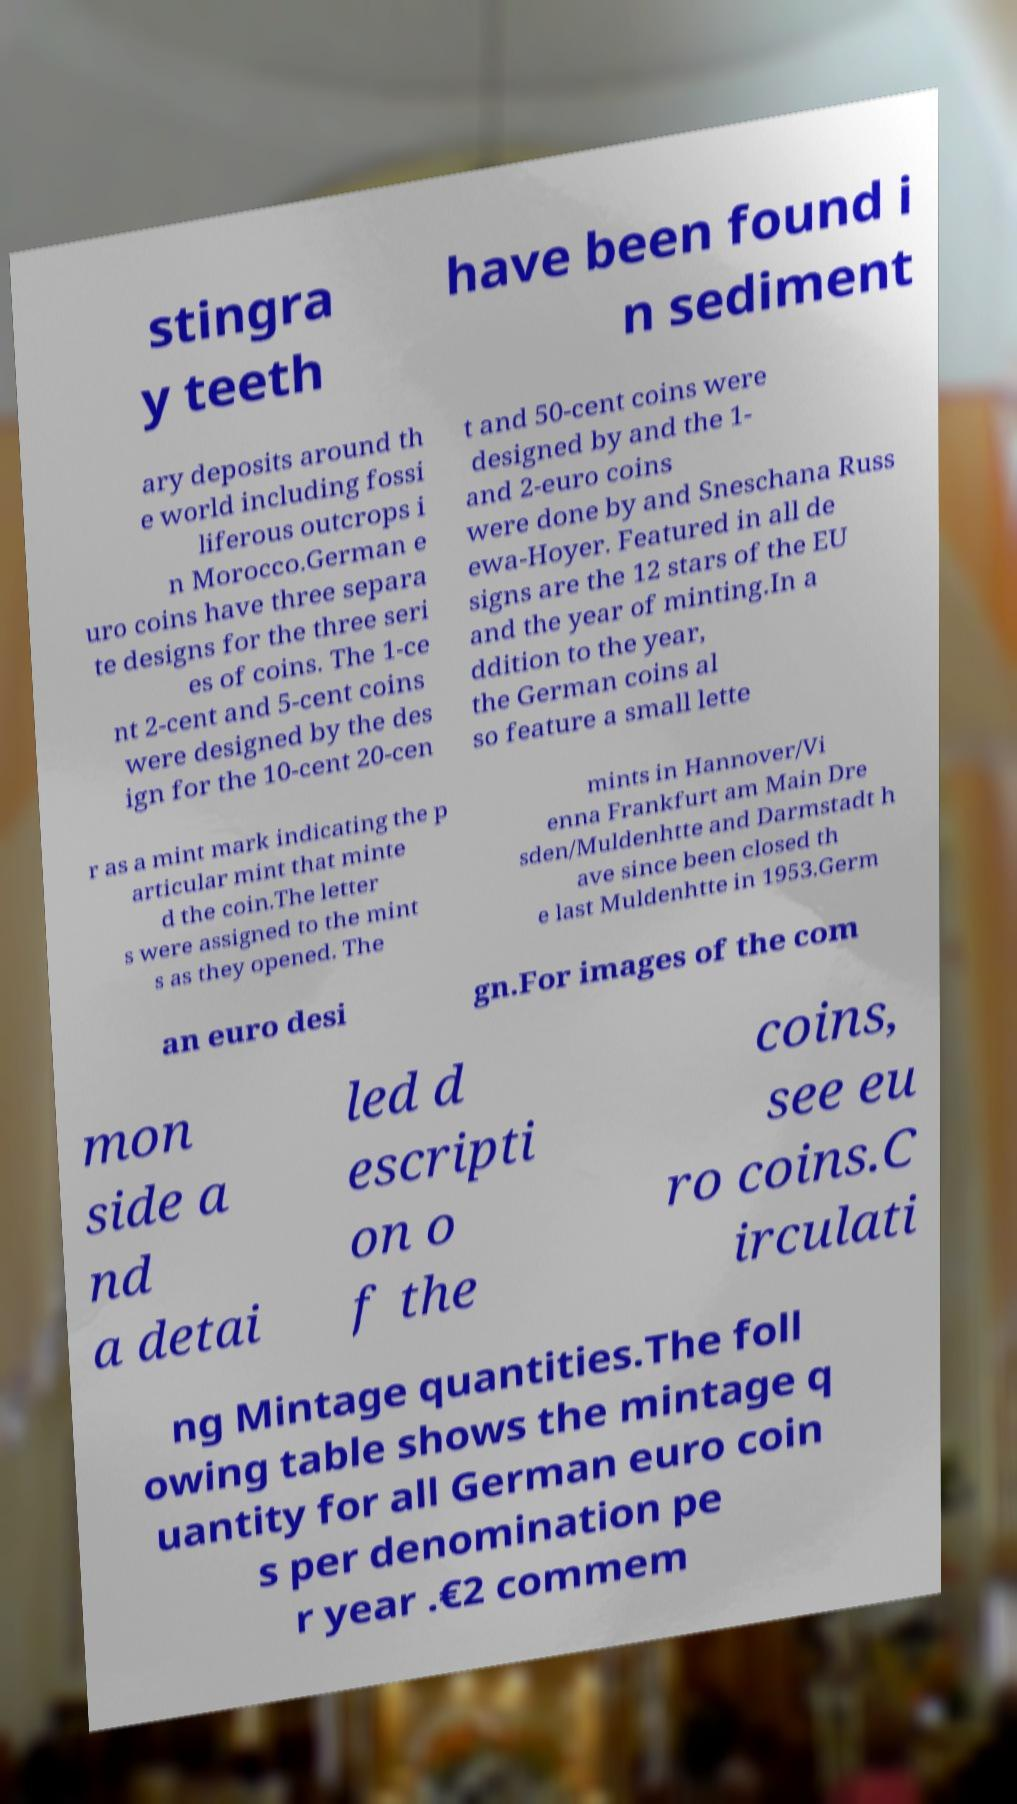Can you read and provide the text displayed in the image?This photo seems to have some interesting text. Can you extract and type it out for me? stingra y teeth have been found i n sediment ary deposits around th e world including fossi liferous outcrops i n Morocco.German e uro coins have three separa te designs for the three seri es of coins. The 1-ce nt 2-cent and 5-cent coins were designed by the des ign for the 10-cent 20-cen t and 50-cent coins were designed by and the 1- and 2-euro coins were done by and Sneschana Russ ewa-Hoyer. Featured in all de signs are the 12 stars of the EU and the year of minting.In a ddition to the year, the German coins al so feature a small lette r as a mint mark indicating the p articular mint that minte d the coin.The letter s were assigned to the mint s as they opened. The mints in Hannover/Vi enna Frankfurt am Main Dre sden/Muldenhtte and Darmstadt h ave since been closed th e last Muldenhtte in 1953.Germ an euro desi gn.For images of the com mon side a nd a detai led d escripti on o f the coins, see eu ro coins.C irculati ng Mintage quantities.The foll owing table shows the mintage q uantity for all German euro coin s per denomination pe r year .€2 commem 